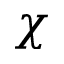Convert formula to latex. <formula><loc_0><loc_0><loc_500><loc_500>\chi</formula> 